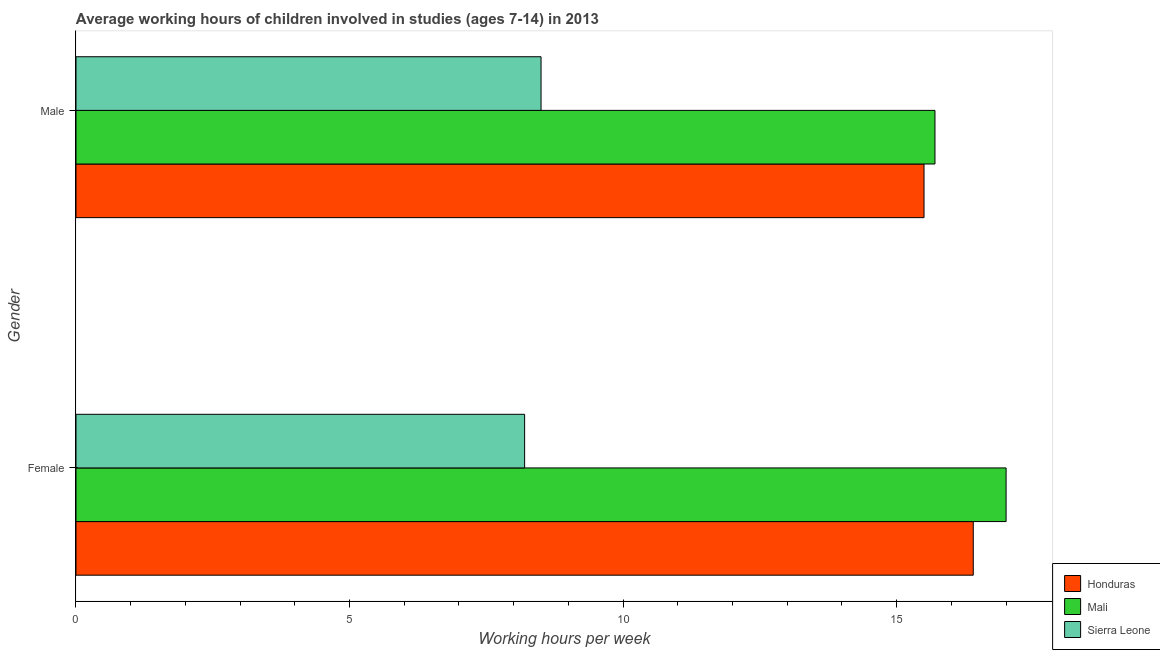How many different coloured bars are there?
Your answer should be very brief. 3. Are the number of bars on each tick of the Y-axis equal?
Provide a short and direct response. Yes. What is the label of the 2nd group of bars from the top?
Give a very brief answer. Female. Across all countries, what is the maximum average working hour of female children?
Provide a short and direct response. 17. Across all countries, what is the minimum average working hour of female children?
Your response must be concise. 8.2. In which country was the average working hour of male children maximum?
Provide a succinct answer. Mali. In which country was the average working hour of male children minimum?
Your answer should be very brief. Sierra Leone. What is the total average working hour of female children in the graph?
Provide a short and direct response. 41.6. What is the average average working hour of female children per country?
Provide a short and direct response. 13.87. What is the difference between the average working hour of female children and average working hour of male children in Mali?
Ensure brevity in your answer.  1.3. What is the ratio of the average working hour of female children in Mali to that in Honduras?
Offer a very short reply. 1.04. Is the average working hour of male children in Sierra Leone less than that in Mali?
Your answer should be very brief. Yes. What does the 1st bar from the top in Male represents?
Keep it short and to the point. Sierra Leone. What does the 2nd bar from the bottom in Male represents?
Make the answer very short. Mali. How many countries are there in the graph?
Make the answer very short. 3. What is the difference between two consecutive major ticks on the X-axis?
Your response must be concise. 5. Are the values on the major ticks of X-axis written in scientific E-notation?
Give a very brief answer. No. Does the graph contain grids?
Give a very brief answer. No. What is the title of the graph?
Provide a short and direct response. Average working hours of children involved in studies (ages 7-14) in 2013. Does "Gambia, The" appear as one of the legend labels in the graph?
Your answer should be compact. No. What is the label or title of the X-axis?
Give a very brief answer. Working hours per week. What is the label or title of the Y-axis?
Offer a very short reply. Gender. What is the Working hours per week in Mali in Female?
Ensure brevity in your answer.  17. What is the Working hours per week of Honduras in Male?
Give a very brief answer. 15.5. What is the Working hours per week in Mali in Male?
Offer a very short reply. 15.7. Across all Gender, what is the maximum Working hours per week in Sierra Leone?
Provide a short and direct response. 8.5. Across all Gender, what is the minimum Working hours per week in Honduras?
Offer a terse response. 15.5. Across all Gender, what is the minimum Working hours per week of Mali?
Provide a short and direct response. 15.7. What is the total Working hours per week in Honduras in the graph?
Your answer should be very brief. 31.9. What is the total Working hours per week of Mali in the graph?
Your answer should be compact. 32.7. What is the difference between the Working hours per week in Honduras in Female and that in Male?
Keep it short and to the point. 0.9. What is the difference between the Working hours per week in Honduras in Female and the Working hours per week in Mali in Male?
Your answer should be compact. 0.7. What is the difference between the Working hours per week of Mali in Female and the Working hours per week of Sierra Leone in Male?
Your answer should be very brief. 8.5. What is the average Working hours per week in Honduras per Gender?
Your answer should be compact. 15.95. What is the average Working hours per week in Mali per Gender?
Offer a very short reply. 16.35. What is the average Working hours per week in Sierra Leone per Gender?
Give a very brief answer. 8.35. What is the difference between the Working hours per week in Honduras and Working hours per week in Mali in Female?
Give a very brief answer. -0.6. What is the difference between the Working hours per week in Honduras and Working hours per week in Sierra Leone in Female?
Provide a succinct answer. 8.2. What is the difference between the Working hours per week of Honduras and Working hours per week of Mali in Male?
Give a very brief answer. -0.2. What is the difference between the Working hours per week in Honduras and Working hours per week in Sierra Leone in Male?
Offer a very short reply. 7. What is the ratio of the Working hours per week in Honduras in Female to that in Male?
Your answer should be compact. 1.06. What is the ratio of the Working hours per week of Mali in Female to that in Male?
Give a very brief answer. 1.08. What is the ratio of the Working hours per week in Sierra Leone in Female to that in Male?
Keep it short and to the point. 0.96. What is the difference between the highest and the second highest Working hours per week in Honduras?
Your answer should be compact. 0.9. What is the difference between the highest and the second highest Working hours per week in Sierra Leone?
Offer a terse response. 0.3. What is the difference between the highest and the lowest Working hours per week in Mali?
Give a very brief answer. 1.3. 